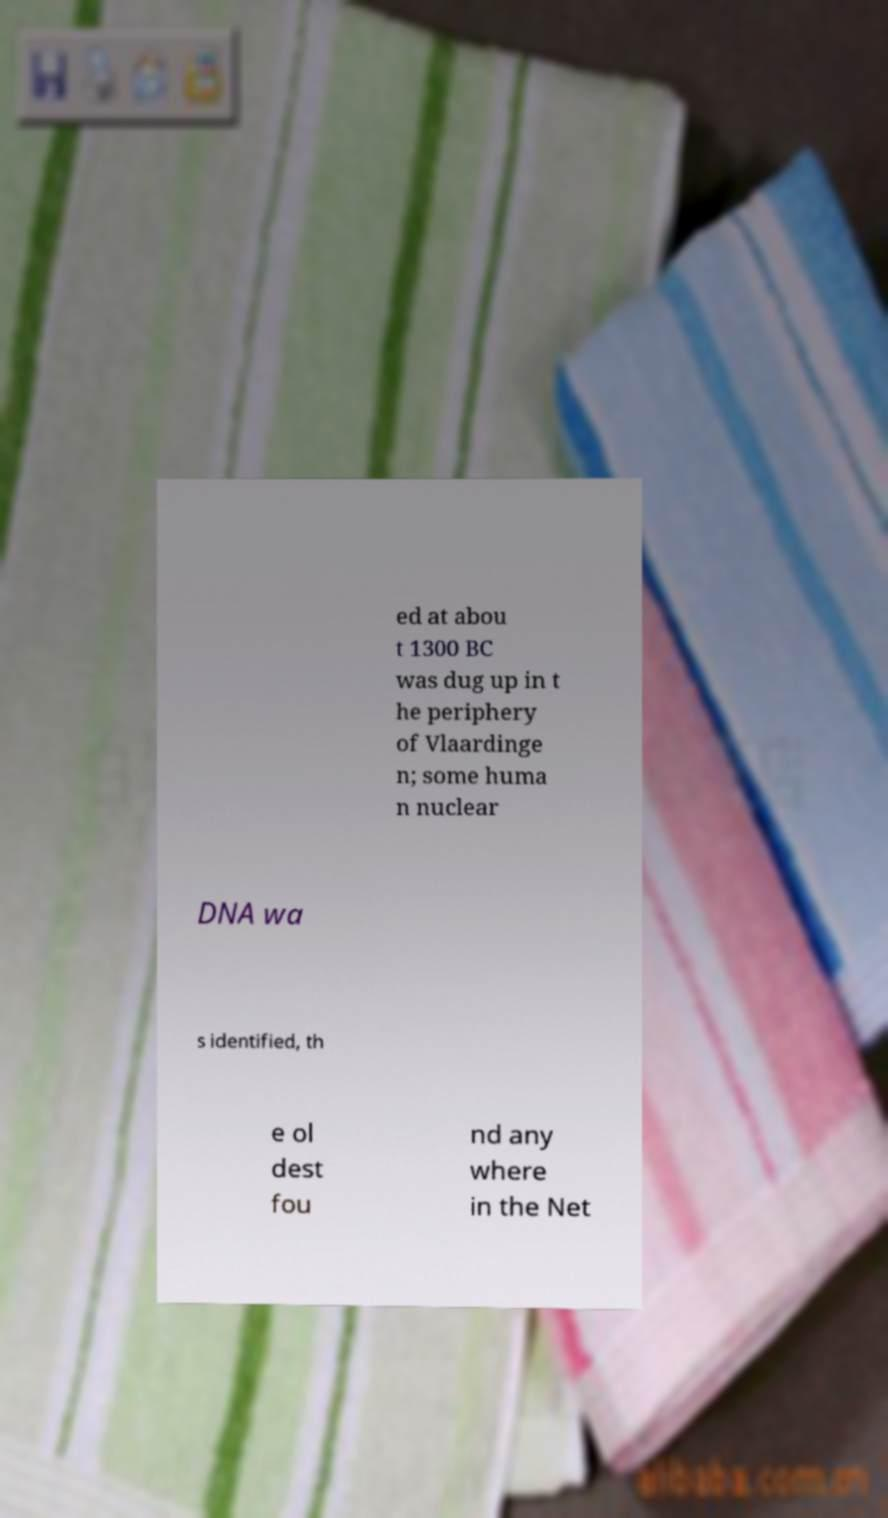There's text embedded in this image that I need extracted. Can you transcribe it verbatim? ed at abou t 1300 BC was dug up in t he periphery of Vlaardinge n; some huma n nuclear DNA wa s identified, th e ol dest fou nd any where in the Net 